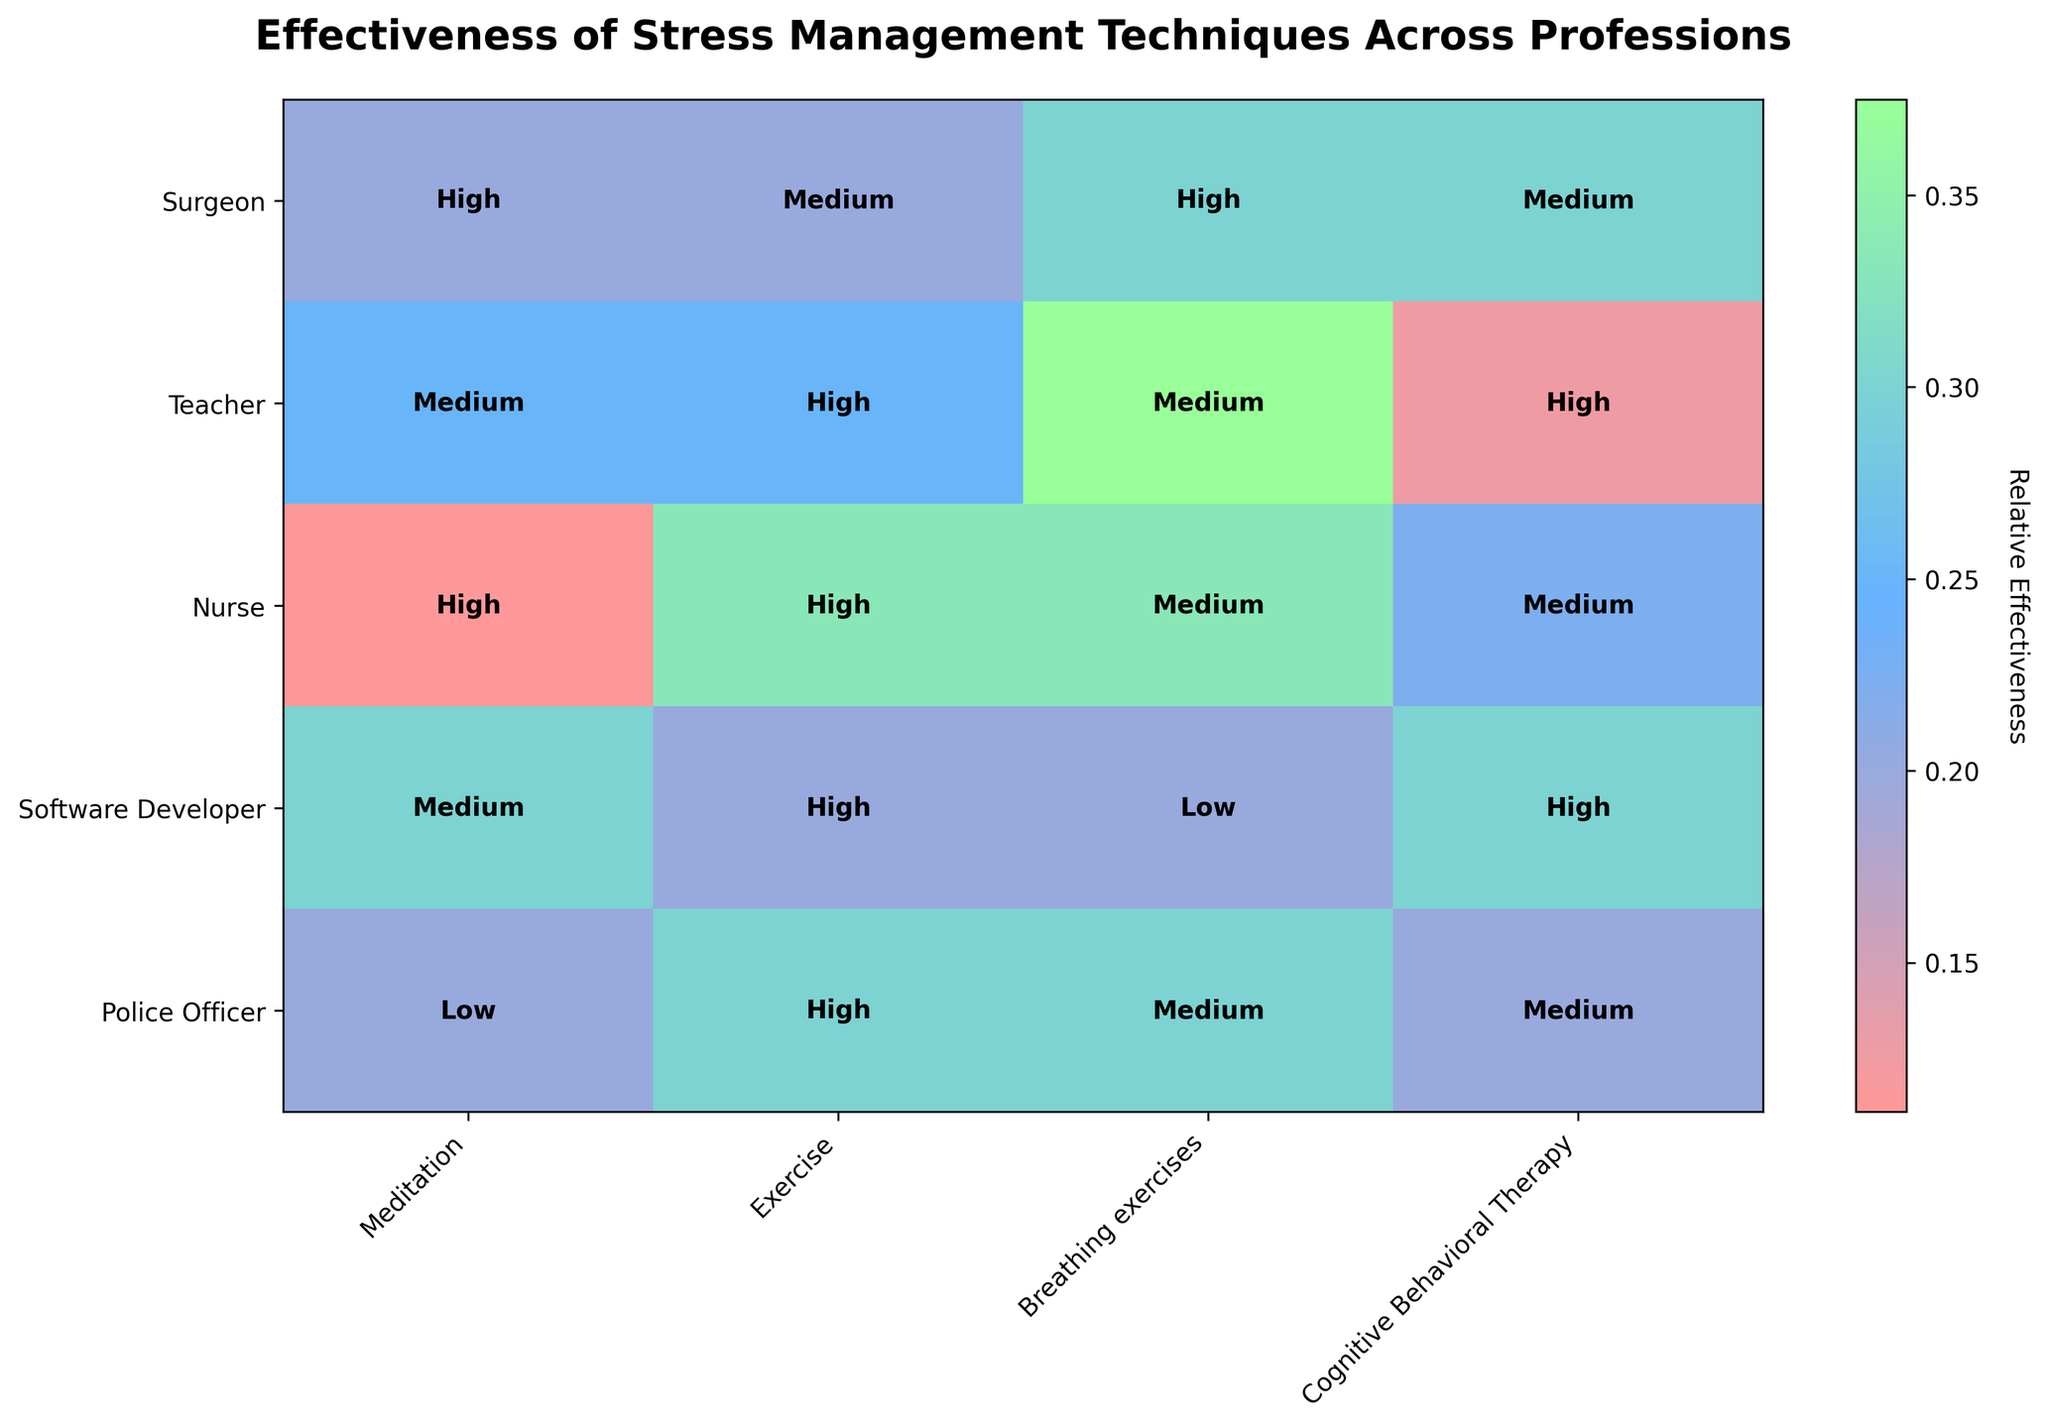What's the title of the figure? The title usually can be found at the top of the figure. Here, it reads: "Effectiveness of Stress Management Techniques Across Professions."
Answer: Effectiveness of Stress Management Techniques Across Professions How are different effectiveness levels represented in the plot? The mosaic plot uses colors to represent different levels of effectiveness: low, medium, and high. These colors range from lighter to darker shades.
Answer: Different colors Which profession shows high effectiveness for both meditation and exercise? Locate the 'High' label in the rows for each profession under the columns for meditation and exercise. Only nurses show 'High' effectiveness in both techniques.
Answer: Nurse Which technique is rated as high effectiveness across the most professions? Scan the columns to see where 'High' is most frequently labeled. Exercise shows high effectiveness in three professions: Teachers, Nurses, and Software Developers.
Answer: Exercise For which profession is meditation rated as low effectiveness? Look at the meditation column and find the 'Low' label across the professions. Only Police Officers have 'Low' effectiveness for meditation.
Answer: Police Officer How does the effectiveness of Cognitive Behavioral Therapy compare between Teachers and Nurses? Find the effectiveness ratings for Cognitive Behavioral Therapy for both Teachers and Nurses. Teachers have a 'High' rating, while Nurses have a 'Medium' rating.
Answer: Teachers have higher effectiveness Which professions have medium effectiveness for breathing exercises? Look at the breathing exercises column and list the professions with a 'Medium' label. These are Teachers, Nurses, and Police Officers.
Answer: Teachers, Nurses, Police Officers What is the relative effectiveness score for software developers and meditation in the plot? The visualization uses a custom colormap to indicate relative scores. 'Medium' effectiveness for meditation in software developers would approximately translate to a relative score of 2.
Answer: Approximately 2 Considering the sum of the relative scores, which profession seems to have the highest average effectiveness across all techniques? Sum up the relative scores for each effectiveness label (Low=1, Medium=2, High=3) per profession and find the average. Nurses have consistently high scores: High, High, Medium, Medium (3+3+2+2)/4 = 2.5. Compare this average with others.
Answer: Nurse What trend do you observe in the effectiveness of Meditation across professions? Observe the color gradient and labels in the meditation column across different professions to detect a pattern. Surgeons, Nurses have ‘High’, Teachers, Software Developers have 'Medium', and Police Officers have 'Low'. The effectiveness decreases from medical-related professions to non-medical ones.
Answer: Higher in medical professions 